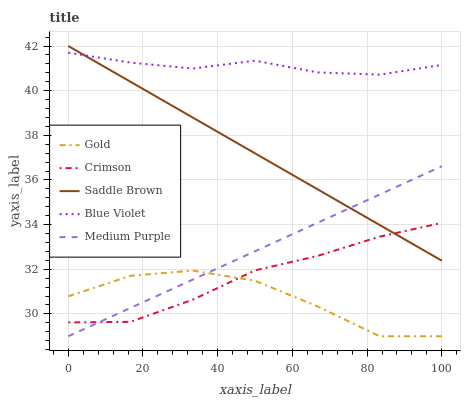Does Gold have the minimum area under the curve?
Answer yes or no. Yes. Does Blue Violet have the maximum area under the curve?
Answer yes or no. Yes. Does Medium Purple have the minimum area under the curve?
Answer yes or no. No. Does Medium Purple have the maximum area under the curve?
Answer yes or no. No. Is Medium Purple the smoothest?
Answer yes or no. Yes. Is Gold the roughest?
Answer yes or no. Yes. Is Blue Violet the smoothest?
Answer yes or no. No. Is Blue Violet the roughest?
Answer yes or no. No. Does Medium Purple have the lowest value?
Answer yes or no. Yes. Does Blue Violet have the lowest value?
Answer yes or no. No. Does Saddle Brown have the highest value?
Answer yes or no. Yes. Does Medium Purple have the highest value?
Answer yes or no. No. Is Crimson less than Blue Violet?
Answer yes or no. Yes. Is Blue Violet greater than Crimson?
Answer yes or no. Yes. Does Saddle Brown intersect Crimson?
Answer yes or no. Yes. Is Saddle Brown less than Crimson?
Answer yes or no. No. Is Saddle Brown greater than Crimson?
Answer yes or no. No. Does Crimson intersect Blue Violet?
Answer yes or no. No. 